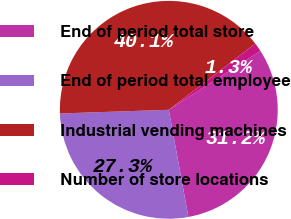<chart> <loc_0><loc_0><loc_500><loc_500><pie_chart><fcel>End of period total store<fcel>End of period total employee<fcel>Industrial vending machines<fcel>Number of store locations<nl><fcel>31.22%<fcel>27.34%<fcel>40.14%<fcel>1.3%<nl></chart> 